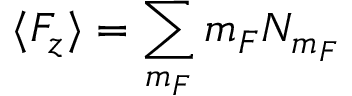<formula> <loc_0><loc_0><loc_500><loc_500>\langle F _ { z } \rangle = \sum _ { m _ { F } } m _ { F } N _ { m _ { F } }</formula> 